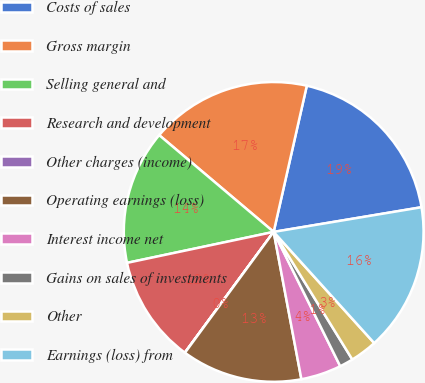Convert chart. <chart><loc_0><loc_0><loc_500><loc_500><pie_chart><fcel>Costs of sales<fcel>Gross margin<fcel>Selling general and<fcel>Research and development<fcel>Other charges (income)<fcel>Operating earnings (loss)<fcel>Interest income net<fcel>Gains on sales of investments<fcel>Other<fcel>Earnings (loss) from<nl><fcel>18.82%<fcel>17.38%<fcel>14.48%<fcel>11.59%<fcel>0.02%<fcel>13.04%<fcel>4.36%<fcel>1.47%<fcel>2.91%<fcel>15.93%<nl></chart> 